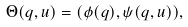<formula> <loc_0><loc_0><loc_500><loc_500>\Theta ( q , u ) = ( \phi ( q ) , \psi ( q , u ) ) ,</formula> 